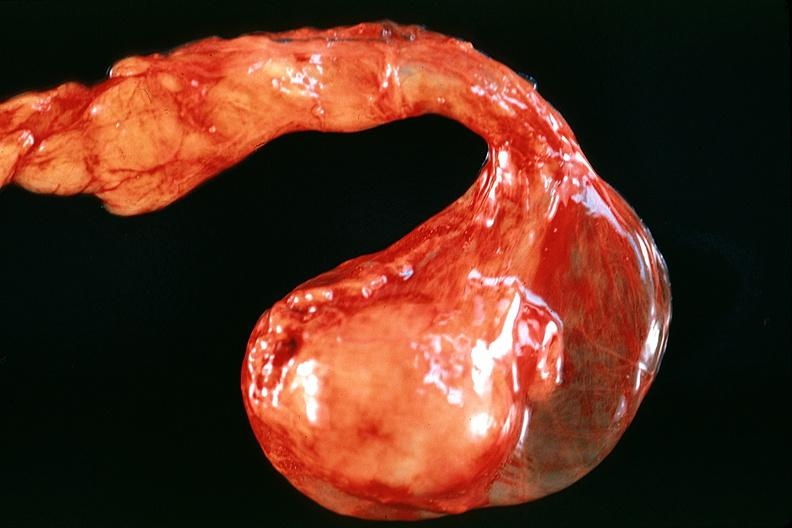does this image show testes, atrophy?
Answer the question using a single word or phrase. Yes 